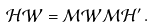<formula> <loc_0><loc_0><loc_500><loc_500>\mathcal { H W } = \mathcal { M W M H ^ { \prime } } \, .</formula> 